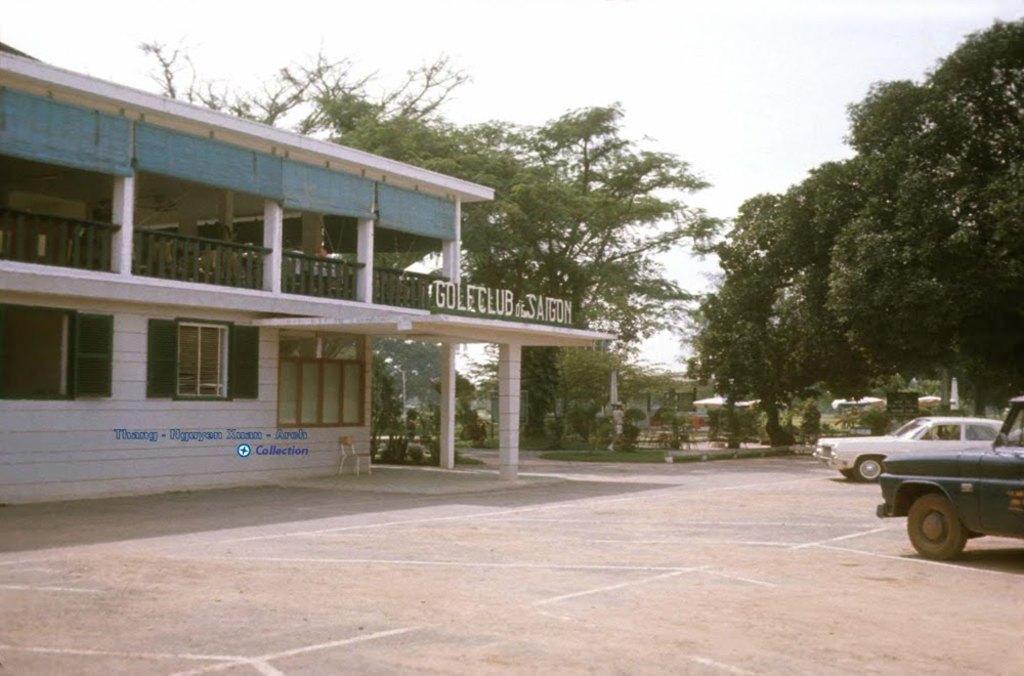Could you give a brief overview of what you see in this image? In this picture I can observe a building on the left side. On the right side there are two cars parked in the parking lot. In the background there are trees and sky. 